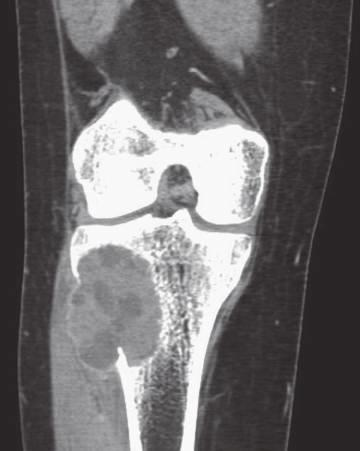what shows eccentric aneurysmal bone cyst of tibia?
Answer the question using a single word or phrase. Coronal computed axial tomography scan 